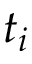<formula> <loc_0><loc_0><loc_500><loc_500>t _ { i }</formula> 